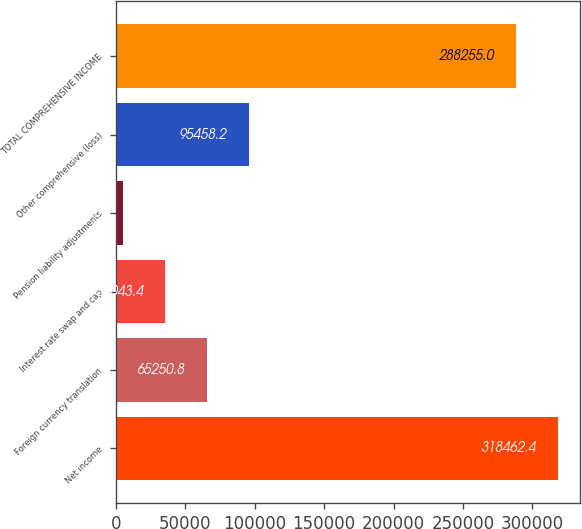Convert chart. <chart><loc_0><loc_0><loc_500><loc_500><bar_chart><fcel>Net income<fcel>Foreign currency translation<fcel>Interest rate swap and cap<fcel>Pension liability adjustments<fcel>Other comprehensive (loss)<fcel>TOTAL COMPREHENSIVE INCOME<nl><fcel>318462<fcel>65250.8<fcel>35043.4<fcel>4836<fcel>95458.2<fcel>288255<nl></chart> 